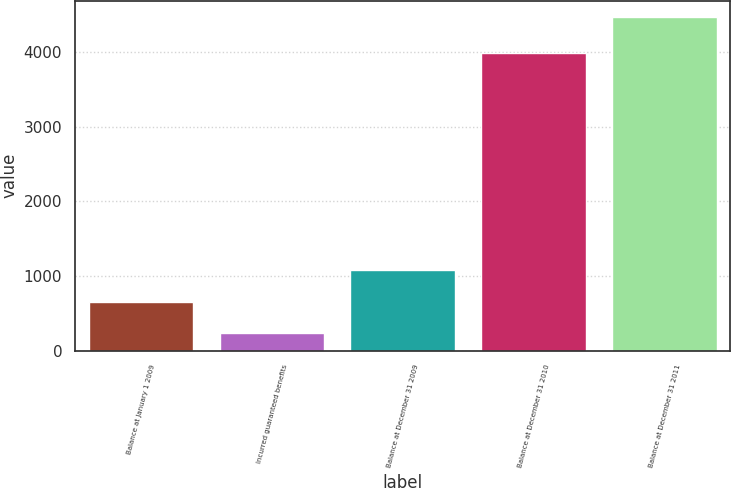Convert chart. <chart><loc_0><loc_0><loc_500><loc_500><bar_chart><fcel>Balance at January 1 2009<fcel>Incurred guaranteed benefits<fcel>Balance at December 31 2009<fcel>Balance at December 31 2010<fcel>Balance at December 31 2011<nl><fcel>656<fcel>233<fcel>1079<fcel>3991<fcel>4463<nl></chart> 